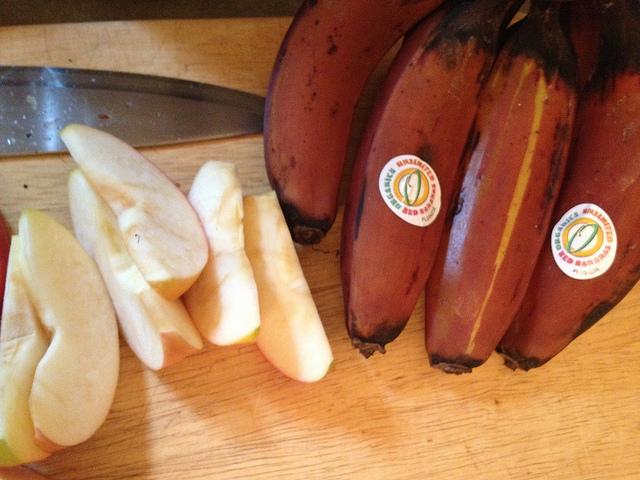Besides bananas, what fruit is showing?
Quick response, please. Apples. Has the knife been used?
Keep it brief. Yes. Are the bananas having tags?
Concise answer only. Yes. What other ingredients besides the carrots and onion go in the beef stew?
Quick response, please. Beef. 